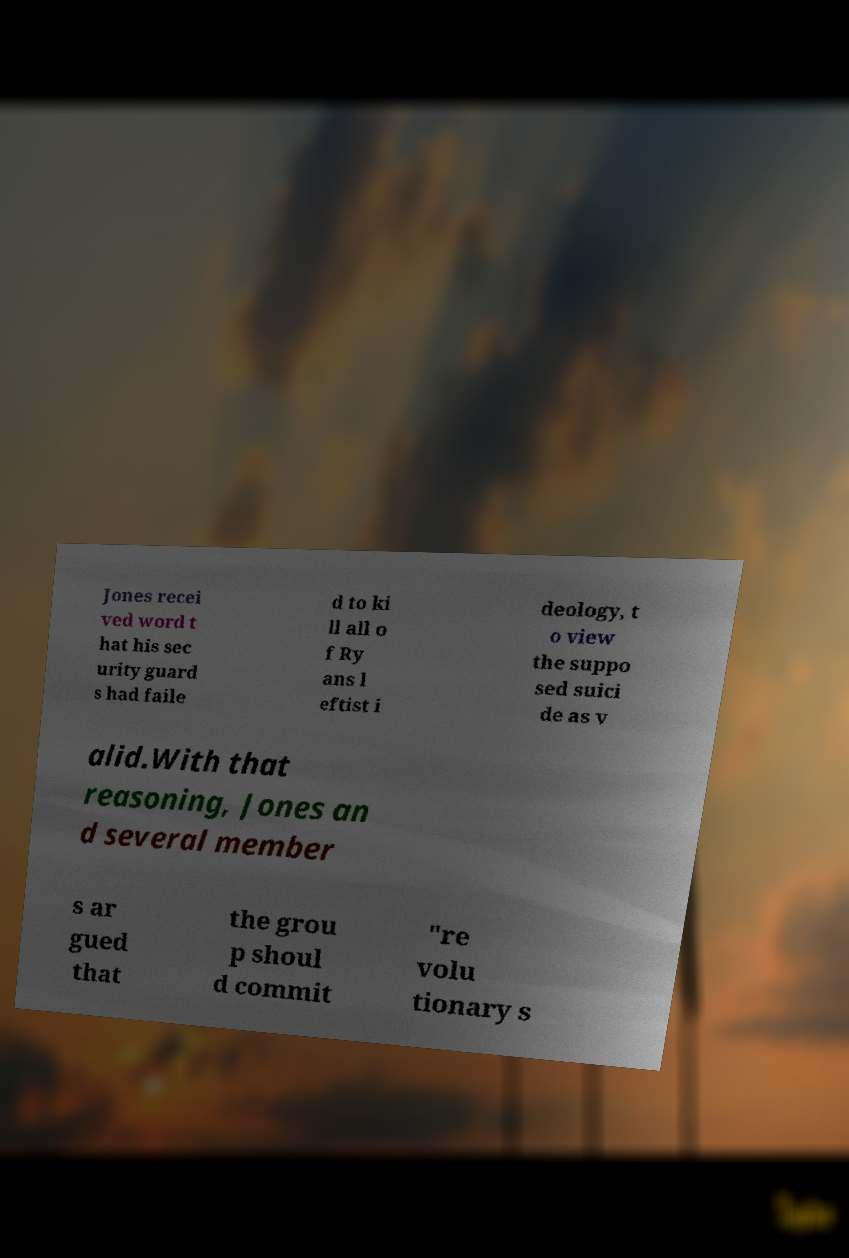What messages or text are displayed in this image? I need them in a readable, typed format. Jones recei ved word t hat his sec urity guard s had faile d to ki ll all o f Ry ans l eftist i deology, t o view the suppo sed suici de as v alid.With that reasoning, Jones an d several member s ar gued that the grou p shoul d commit "re volu tionary s 